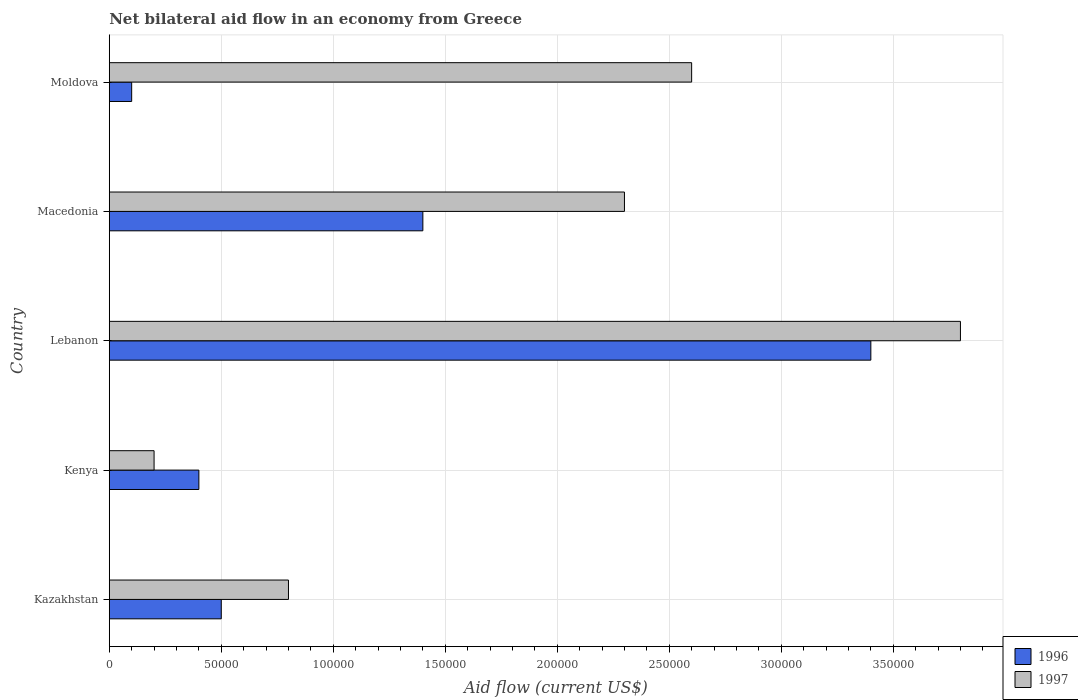How many groups of bars are there?
Your response must be concise. 5. Are the number of bars per tick equal to the number of legend labels?
Ensure brevity in your answer.  Yes. How many bars are there on the 2nd tick from the top?
Keep it short and to the point. 2. How many bars are there on the 4th tick from the bottom?
Provide a short and direct response. 2. What is the label of the 4th group of bars from the top?
Provide a short and direct response. Kenya. In how many cases, is the number of bars for a given country not equal to the number of legend labels?
Keep it short and to the point. 0. What is the net bilateral aid flow in 1997 in Moldova?
Give a very brief answer. 2.60e+05. Across all countries, what is the maximum net bilateral aid flow in 1996?
Offer a terse response. 3.40e+05. Across all countries, what is the minimum net bilateral aid flow in 1997?
Offer a terse response. 2.00e+04. In which country was the net bilateral aid flow in 1997 maximum?
Make the answer very short. Lebanon. In which country was the net bilateral aid flow in 1996 minimum?
Offer a terse response. Moldova. What is the total net bilateral aid flow in 1997 in the graph?
Provide a short and direct response. 9.70e+05. What is the difference between the net bilateral aid flow in 1996 in Lebanon and that in Macedonia?
Your answer should be very brief. 2.00e+05. What is the average net bilateral aid flow in 1997 per country?
Provide a short and direct response. 1.94e+05. What is the ratio of the net bilateral aid flow in 1996 in Kazakhstan to that in Macedonia?
Offer a terse response. 0.36. Is the net bilateral aid flow in 1997 in Kazakhstan less than that in Kenya?
Your answer should be very brief. No. Is the difference between the net bilateral aid flow in 1997 in Kazakhstan and Kenya greater than the difference between the net bilateral aid flow in 1996 in Kazakhstan and Kenya?
Your answer should be very brief. Yes. What is the difference between the highest and the second highest net bilateral aid flow in 1997?
Make the answer very short. 1.20e+05. What is the difference between the highest and the lowest net bilateral aid flow in 1997?
Keep it short and to the point. 3.60e+05. What does the 1st bar from the top in Kenya represents?
Offer a terse response. 1997. What does the 2nd bar from the bottom in Lebanon represents?
Ensure brevity in your answer.  1997. How many bars are there?
Your answer should be very brief. 10. What is the difference between two consecutive major ticks on the X-axis?
Provide a short and direct response. 5.00e+04. Does the graph contain any zero values?
Offer a very short reply. No. Does the graph contain grids?
Offer a very short reply. Yes. How many legend labels are there?
Offer a very short reply. 2. How are the legend labels stacked?
Provide a succinct answer. Vertical. What is the title of the graph?
Ensure brevity in your answer.  Net bilateral aid flow in an economy from Greece. Does "1987" appear as one of the legend labels in the graph?
Provide a succinct answer. No. What is the Aid flow (current US$) of 1996 in Kazakhstan?
Ensure brevity in your answer.  5.00e+04. What is the Aid flow (current US$) in 1997 in Kazakhstan?
Give a very brief answer. 8.00e+04. What is the Aid flow (current US$) of 1996 in Lebanon?
Give a very brief answer. 3.40e+05. What is the Aid flow (current US$) in 1996 in Moldova?
Offer a very short reply. 10000. Across all countries, what is the minimum Aid flow (current US$) of 1996?
Provide a short and direct response. 10000. What is the total Aid flow (current US$) in 1996 in the graph?
Offer a very short reply. 5.80e+05. What is the total Aid flow (current US$) in 1997 in the graph?
Your response must be concise. 9.70e+05. What is the difference between the Aid flow (current US$) of 1996 in Kazakhstan and that in Kenya?
Your answer should be compact. 10000. What is the difference between the Aid flow (current US$) of 1997 in Kazakhstan and that in Kenya?
Offer a very short reply. 6.00e+04. What is the difference between the Aid flow (current US$) in 1996 in Kazakhstan and that in Lebanon?
Your response must be concise. -2.90e+05. What is the difference between the Aid flow (current US$) in 1996 in Kazakhstan and that in Macedonia?
Provide a succinct answer. -9.00e+04. What is the difference between the Aid flow (current US$) in 1997 in Kazakhstan and that in Macedonia?
Keep it short and to the point. -1.50e+05. What is the difference between the Aid flow (current US$) of 1997 in Kazakhstan and that in Moldova?
Your response must be concise. -1.80e+05. What is the difference between the Aid flow (current US$) in 1997 in Kenya and that in Lebanon?
Offer a very short reply. -3.60e+05. What is the difference between the Aid flow (current US$) of 1997 in Kenya and that in Macedonia?
Keep it short and to the point. -2.10e+05. What is the difference between the Aid flow (current US$) in 1996 in Lebanon and that in Macedonia?
Your answer should be compact. 2.00e+05. What is the difference between the Aid flow (current US$) in 1997 in Lebanon and that in Moldova?
Your answer should be very brief. 1.20e+05. What is the difference between the Aid flow (current US$) in 1996 in Kazakhstan and the Aid flow (current US$) in 1997 in Lebanon?
Offer a very short reply. -3.30e+05. What is the difference between the Aid flow (current US$) in 1996 in Kazakhstan and the Aid flow (current US$) in 1997 in Macedonia?
Your answer should be compact. -1.80e+05. What is the difference between the Aid flow (current US$) in 1996 in Kazakhstan and the Aid flow (current US$) in 1997 in Moldova?
Make the answer very short. -2.10e+05. What is the difference between the Aid flow (current US$) in 1996 in Kenya and the Aid flow (current US$) in 1997 in Lebanon?
Make the answer very short. -3.40e+05. What is the difference between the Aid flow (current US$) of 1996 in Kenya and the Aid flow (current US$) of 1997 in Macedonia?
Offer a very short reply. -1.90e+05. What is the difference between the Aid flow (current US$) of 1996 in Lebanon and the Aid flow (current US$) of 1997 in Macedonia?
Keep it short and to the point. 1.10e+05. What is the difference between the Aid flow (current US$) of 1996 in Macedonia and the Aid flow (current US$) of 1997 in Moldova?
Provide a short and direct response. -1.20e+05. What is the average Aid flow (current US$) of 1996 per country?
Provide a succinct answer. 1.16e+05. What is the average Aid flow (current US$) in 1997 per country?
Provide a short and direct response. 1.94e+05. What is the ratio of the Aid flow (current US$) of 1997 in Kazakhstan to that in Kenya?
Provide a short and direct response. 4. What is the ratio of the Aid flow (current US$) in 1996 in Kazakhstan to that in Lebanon?
Keep it short and to the point. 0.15. What is the ratio of the Aid flow (current US$) of 1997 in Kazakhstan to that in Lebanon?
Ensure brevity in your answer.  0.21. What is the ratio of the Aid flow (current US$) of 1996 in Kazakhstan to that in Macedonia?
Make the answer very short. 0.36. What is the ratio of the Aid flow (current US$) of 1997 in Kazakhstan to that in Macedonia?
Offer a terse response. 0.35. What is the ratio of the Aid flow (current US$) of 1996 in Kazakhstan to that in Moldova?
Make the answer very short. 5. What is the ratio of the Aid flow (current US$) of 1997 in Kazakhstan to that in Moldova?
Provide a succinct answer. 0.31. What is the ratio of the Aid flow (current US$) of 1996 in Kenya to that in Lebanon?
Provide a succinct answer. 0.12. What is the ratio of the Aid flow (current US$) in 1997 in Kenya to that in Lebanon?
Offer a terse response. 0.05. What is the ratio of the Aid flow (current US$) in 1996 in Kenya to that in Macedonia?
Provide a succinct answer. 0.29. What is the ratio of the Aid flow (current US$) in 1997 in Kenya to that in Macedonia?
Provide a short and direct response. 0.09. What is the ratio of the Aid flow (current US$) of 1996 in Kenya to that in Moldova?
Ensure brevity in your answer.  4. What is the ratio of the Aid flow (current US$) of 1997 in Kenya to that in Moldova?
Make the answer very short. 0.08. What is the ratio of the Aid flow (current US$) of 1996 in Lebanon to that in Macedonia?
Your response must be concise. 2.43. What is the ratio of the Aid flow (current US$) of 1997 in Lebanon to that in Macedonia?
Your answer should be compact. 1.65. What is the ratio of the Aid flow (current US$) of 1997 in Lebanon to that in Moldova?
Your answer should be compact. 1.46. What is the ratio of the Aid flow (current US$) in 1997 in Macedonia to that in Moldova?
Make the answer very short. 0.88. What is the difference between the highest and the second highest Aid flow (current US$) in 1997?
Your response must be concise. 1.20e+05. 